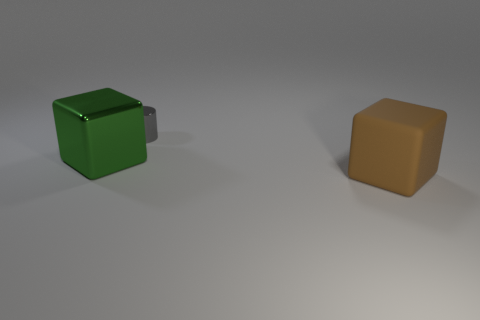Add 2 large metallic cylinders. How many objects exist? 5 Subtract all cylinders. How many objects are left? 2 Subtract all small metallic objects. Subtract all rubber blocks. How many objects are left? 1 Add 2 small gray cylinders. How many small gray cylinders are left? 3 Add 1 cylinders. How many cylinders exist? 2 Subtract 1 brown blocks. How many objects are left? 2 